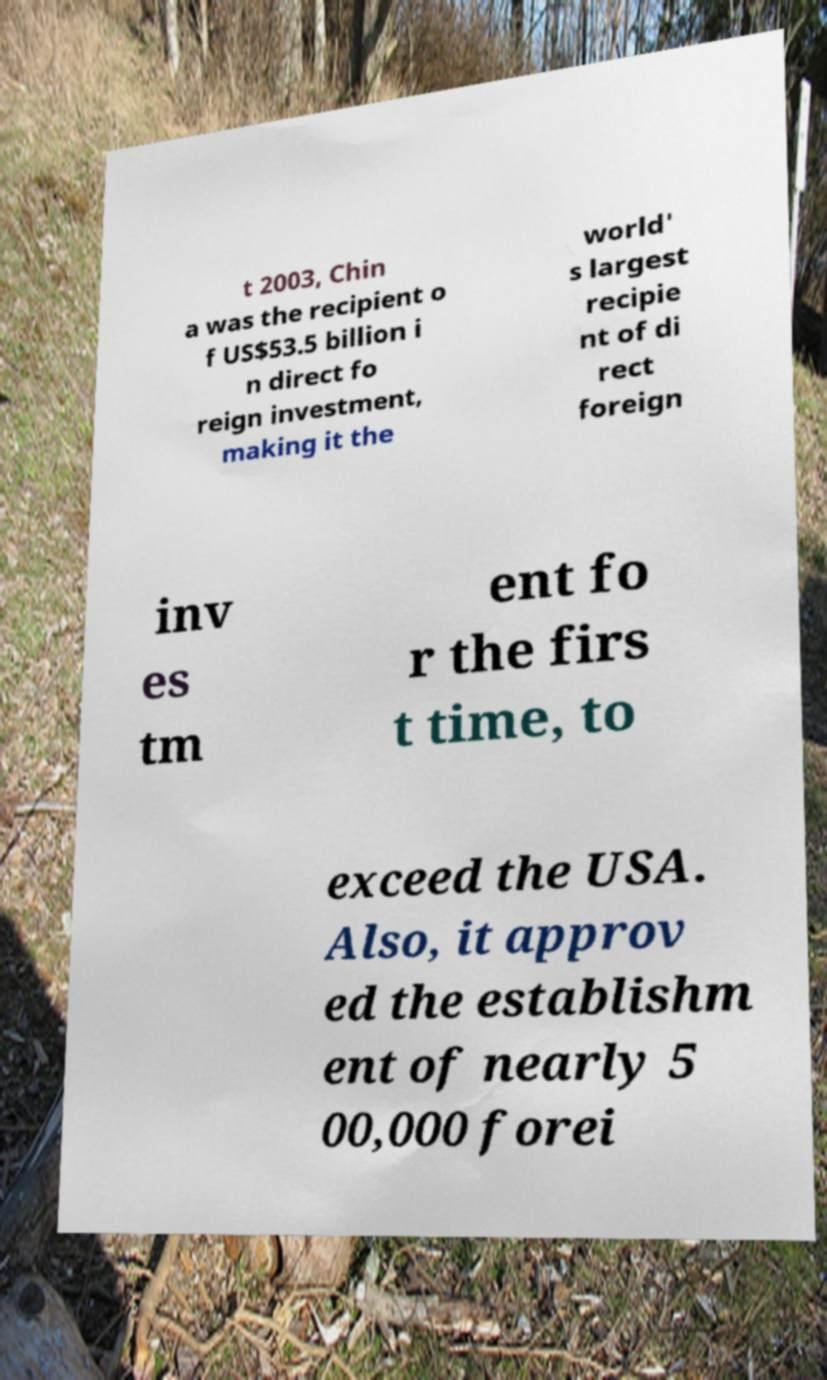What messages or text are displayed in this image? I need them in a readable, typed format. t 2003, Chin a was the recipient o f US$53.5 billion i n direct fo reign investment, making it the world' s largest recipie nt of di rect foreign inv es tm ent fo r the firs t time, to exceed the USA. Also, it approv ed the establishm ent of nearly 5 00,000 forei 